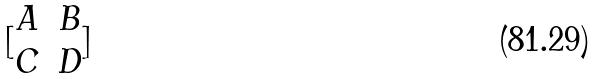Convert formula to latex. <formula><loc_0><loc_0><loc_500><loc_500>[ \begin{matrix} A & B \\ C & D \end{matrix} ]</formula> 